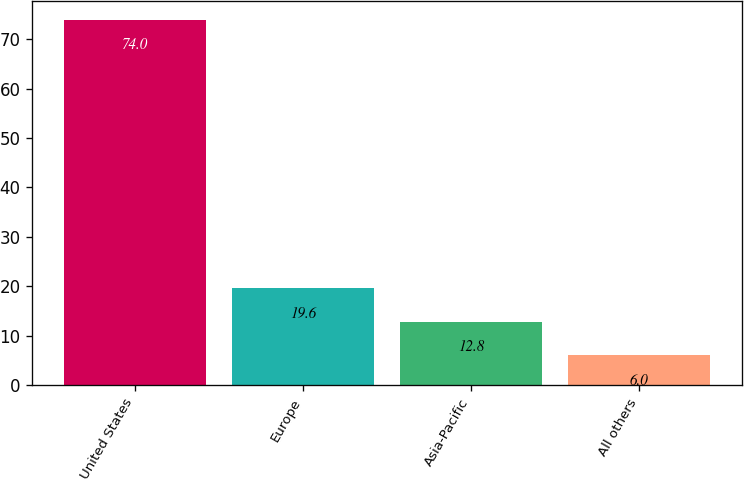Convert chart to OTSL. <chart><loc_0><loc_0><loc_500><loc_500><bar_chart><fcel>United States<fcel>Europe<fcel>Asia-Pacific<fcel>All others<nl><fcel>74<fcel>19.6<fcel>12.8<fcel>6<nl></chart> 